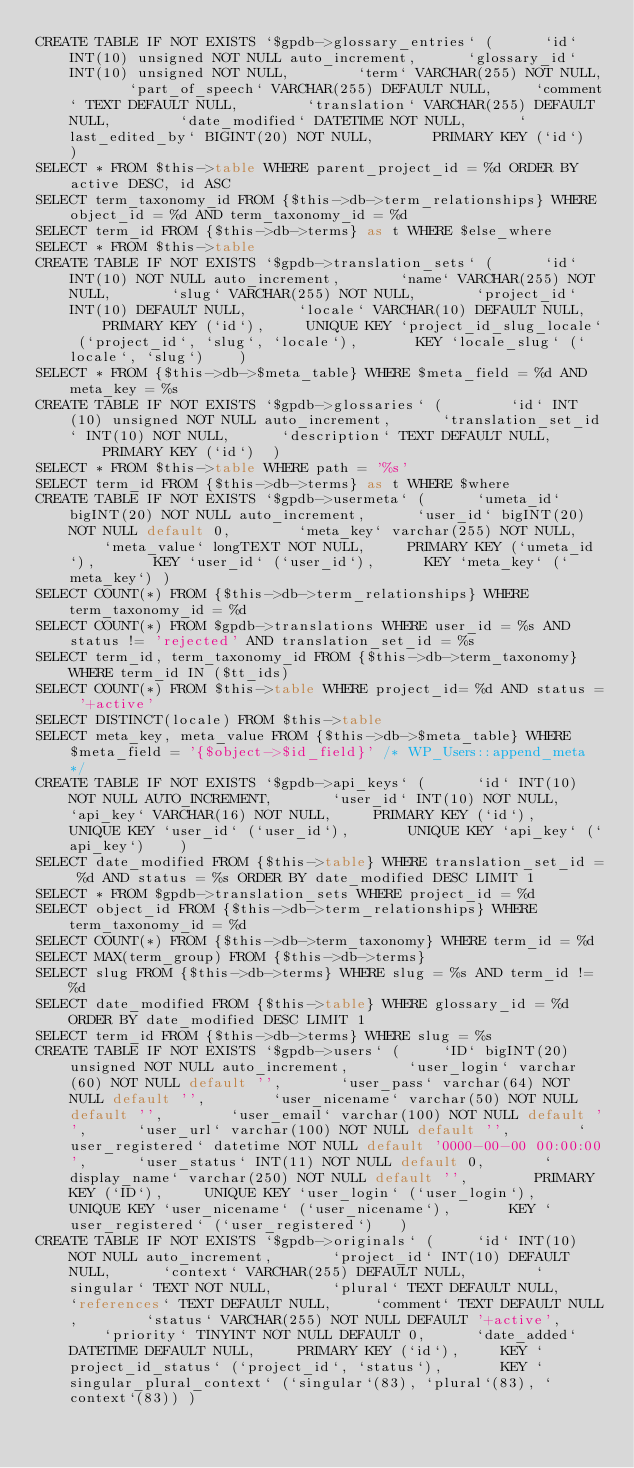Convert code to text. <code><loc_0><loc_0><loc_500><loc_500><_SQL_>CREATE TABLE IF NOT EXISTS `$gpdb->glossary_entries` (		`id` INT(10) unsigned NOT NULL auto_increment,		`glossary_id` INT(10) unsigned NOT NULL,		`term` VARCHAR(255) NOT NULL,		`part_of_speech` VARCHAR(255) DEFAULT NULL,		`comment` TEXT DEFAULT NULL,		`translation` VARCHAR(255) DEFAULT NULL,		`date_modified` DATETIME NOT NULL,		`last_edited_by` BIGINT(20) NOT NULL,		PRIMARY KEY (`id`)	)
SELECT * FROM $this->table WHERE parent_project_id = %d ORDER BY active DESC, id ASC
SELECT term_taxonomy_id FROM {$this->db->term_relationships} WHERE object_id = %d AND term_taxonomy_id = %d
SELECT term_id FROM {$this->db->terms} as t WHERE $else_where
SELECT * FROM $this->table
CREATE TABLE IF NOT EXISTS `$gpdb->translation_sets` (		`id` INT(10) NOT NULL auto_increment,		`name` VARCHAR(255) NOT NULL,		`slug` VARCHAR(255) NOT NULL,		`project_id` INT(10) DEFAULT NULL,		`locale` VARCHAR(10) DEFAULT NULL,		PRIMARY KEY (`id`),		UNIQUE KEY `project_id_slug_locale` (`project_id`, `slug`, `locale`),		KEY `locale_slug` (`locale`, `slug`)	)
SELECT * FROM {$this->db->$meta_table} WHERE $meta_field = %d AND meta_key = %s
CREATE TABLE IF NOT EXISTS `$gpdb->glossaries` (		`id` INT(10) unsigned NOT NULL auto_increment,		`translation_set_id` INT(10) NOT NULL,		`description` TEXT DEFAULT NULL,		PRIMARY KEY (`id`)	)
SELECT * FROM $this->table WHERE path = '%s'
SELECT term_id FROM {$this->db->terms} as t WHERE $where
CREATE TABLE IF NOT EXISTS `$gpdb->usermeta` (		`umeta_id` bigINT(20) NOT NULL auto_increment,		`user_id` bigINT(20) NOT NULL default 0,		`meta_key` varchar(255) NOT NULL,		`meta_value` longTEXT NOT NULL,		PRIMARY KEY (`umeta_id`),		KEY `user_id` (`user_id`),		KEY `meta_key` (`meta_key`)	)
SELECT COUNT(*) FROM {$this->db->term_relationships} WHERE term_taxonomy_id = %d
SELECT COUNT(*) FROM $gpdb->translations WHERE user_id = %s AND status != 'rejected' AND translation_set_id = %s
SELECT term_id, term_taxonomy_id FROM {$this->db->term_taxonomy} WHERE term_id IN ($tt_ids)
SELECT COUNT(*) FROM $this->table WHERE project_id= %d AND status = '+active'
SELECT DISTINCT(locale) FROM $this->table
SELECT meta_key, meta_value FROM {$this->db->$meta_table} WHERE $meta_field = '{$object->$id_field}' /* WP_Users::append_meta */
CREATE TABLE IF NOT EXISTS `$gpdb->api_keys` (		`id` INT(10) NOT NULL AUTO_INCREMENT,		`user_id` INT(10) NOT NULL,		`api_key` VARCHAR(16) NOT NULL,		PRIMARY KEY (`id`),		UNIQUE KEY `user_id` (`user_id`),		UNIQUE KEY `api_key` (`api_key`)	)
SELECT date_modified FROM {$this->table} WHERE translation_set_id = %d AND status = %s ORDER BY date_modified DESC LIMIT 1
SELECT * FROM $gpdb->translation_sets WHERE project_id = %d
SELECT object_id FROM {$this->db->term_relationships} WHERE term_taxonomy_id = %d
SELECT COUNT(*) FROM {$this->db->term_taxonomy} WHERE term_id = %d
SELECT MAX(term_group) FROM {$this->db->terms}
SELECT slug FROM {$this->db->terms} WHERE slug = %s AND term_id != %d
SELECT date_modified FROM {$this->table} WHERE glossary_id = %d ORDER BY date_modified DESC LIMIT 1
SELECT term_id FROM {$this->db->terms} WHERE slug = %s
CREATE TABLE IF NOT EXISTS `$gpdb->users` (		`ID` bigINT(20) unsigned NOT NULL auto_increment,		`user_login` varchar(60) NOT NULL default '',		`user_pass` varchar(64) NOT NULL default '',		`user_nicename` varchar(50) NOT NULL default '',		`user_email` varchar(100) NOT NULL default '',		`user_url` varchar(100) NOT NULL default '',		`user_registered` datetime NOT NULL default '0000-00-00 00:00:00',		`user_status` INT(11) NOT NULL default 0,		`display_name` varchar(250) NOT NULL default '',		PRIMARY KEY (`ID`),		UNIQUE KEY `user_login` (`user_login`),		UNIQUE KEY `user_nicename` (`user_nicename`),		KEY `user_registered` (`user_registered`)	)
CREATE TABLE IF NOT EXISTS `$gpdb->originals` (		`id` INT(10) NOT NULL auto_increment,		`project_id` INT(10) DEFAULT NULL,		`context` VARCHAR(255) DEFAULT NULL,		`singular` TEXT NOT NULL,		`plural` TEXT DEFAULT NULL,		`references` TEXT DEFAULT NULL,		`comment` TEXT DEFAULT NULL,		`status` VARCHAR(255) NOT NULL DEFAULT '+active',		`priority` TINYINT NOT NULL DEFAULT 0,		`date_added` DATETIME DEFAULT NULL,		PRIMARY KEY (`id`),		KEY `project_id_status` (`project_id`, `status`),		KEY `singular_plural_context` (`singular`(83), `plural`(83), `context`(83))	)</code> 